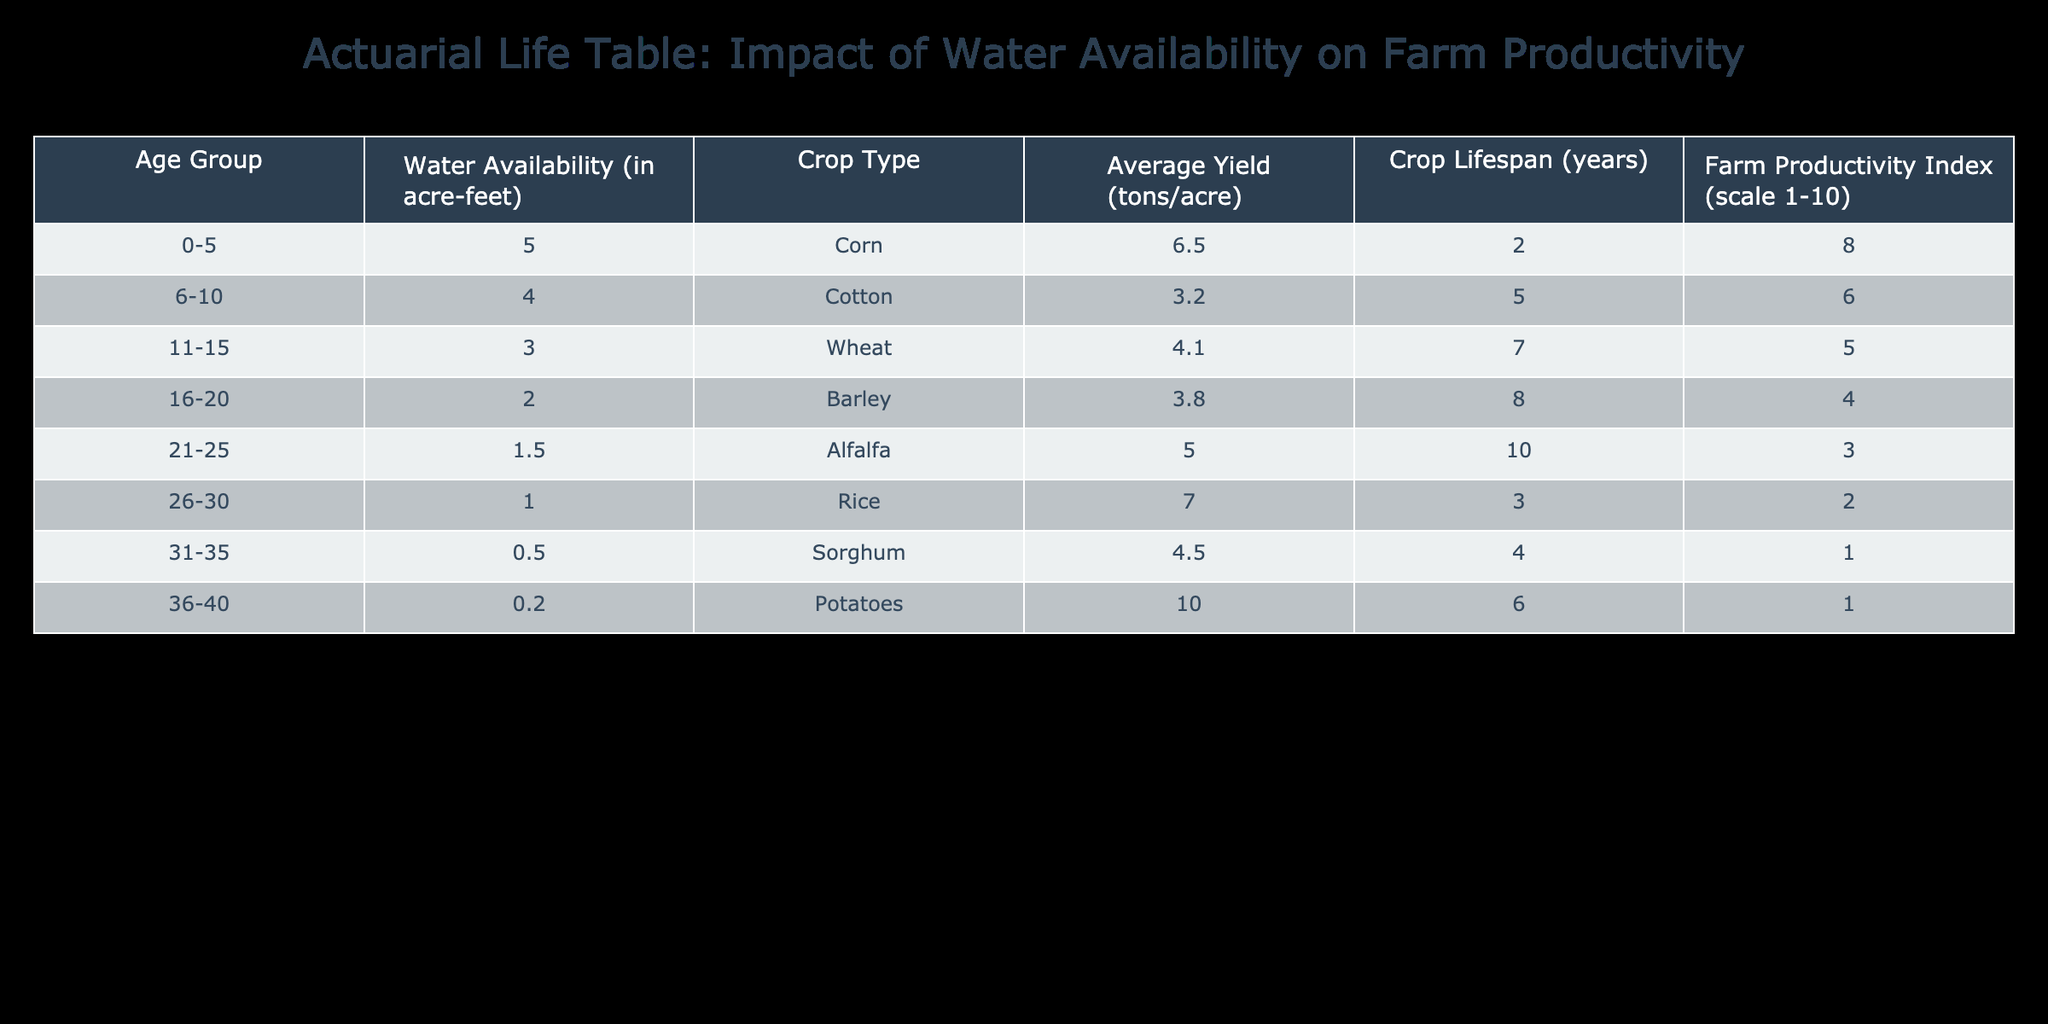What is the average yield of Rice? From the table, the average yield of Rice is listed directly as 7.0 tons per acre.
Answer: 7.0 tons per acre Which crop has the highest farm productivity index? The farm productivity index is highest for Corn, which has an index of 8.
Answer: Corn Is the crop lifespan for Cotton greater than that for Barley? The crop lifespan for Cotton is 5 years, while the crop lifespan for Barley is 8 years. Thus, Cotton's lifespan is not greater than Barley's.
Answer: No What is the total average yield for all crops listed? To calculate the total average yield, we sum the average yields: 6.5 (Corn) + 3.2 (Cotton) + 4.1 (Wheat) + 3.8 (Barley) + 5.0 (Alfalfa) + 7.0 (Rice) + 4.5 (Sorghum) + 10.0 (Potatoes) = 44.1 tons per acre. Then we divide by the number of crops, which is 8. So the total average yield is 44.1 / 8 = 5.5125 tons per acre.
Answer: 5.5125 tons per acre What is the average water availability for crops with a farm productivity index of 1? The only crops with a farm productivity index of 1 are Sorghum (0.5 acre-feet) and Potatoes (0.2 acre-feet). We sum these values: 0.5 + 0.2 = 0.7, and then we divide by the number of crops in this category, which is 2. Therefore, the average water availability is 0.7 / 2 = 0.35 acre-feet.
Answer: 0.35 acre-feet Do crops with lower water availability tend to have shorter crop lifespans? Analyzing the data, as water availability decreases from 5 acre-feet (Corn) to 0.2 acre-feet (Potatoes), the crop lifespans are: 2, 5, 7, 8, 10, 3, 4, 6 years, respectively, showing no clear trend to support the idea that lower water availability leads to shorter lifespans.
Answer: No 